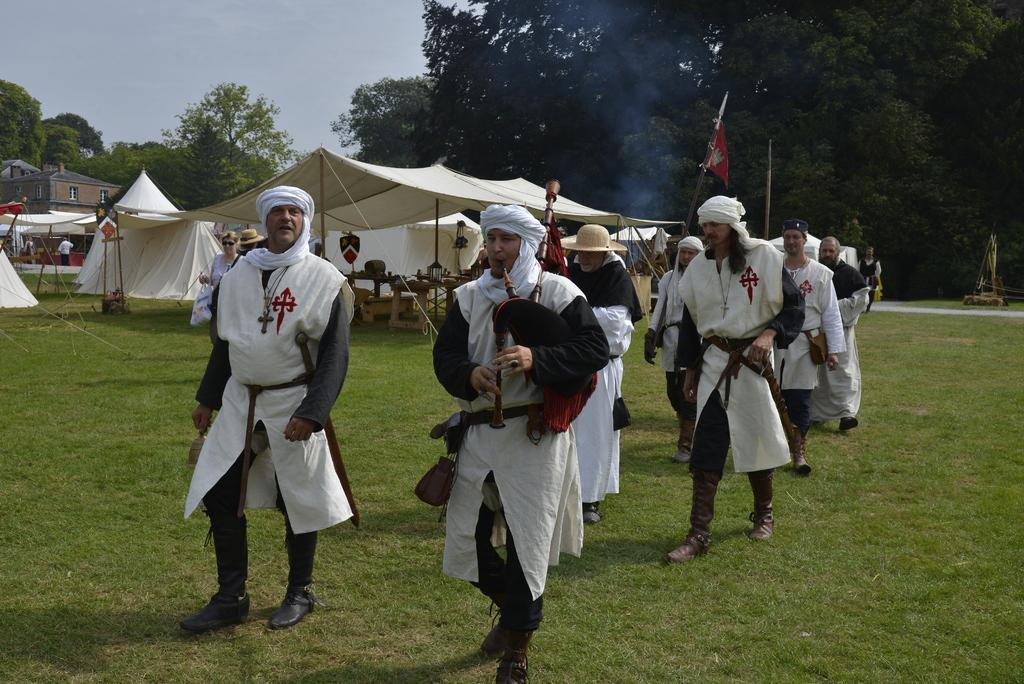What is the person in the image doing? The person is wearing different costumes and walking on the grass. What can be seen in the image besides the person? There is a flag, a tent, houses, trees, smoke, and the sky visible in the image. What is the person's location in relation to the flag? The flag is in the image, but its exact location relative to the person is not specified. What is the background of the image like? The background of the image includes houses, trees, smoke, and the sky. What type of music can be heard coming from the person's thumb in the image? There is no mention of music or a thumb in the image, so it is not possible to determine what type of music might be heard. 